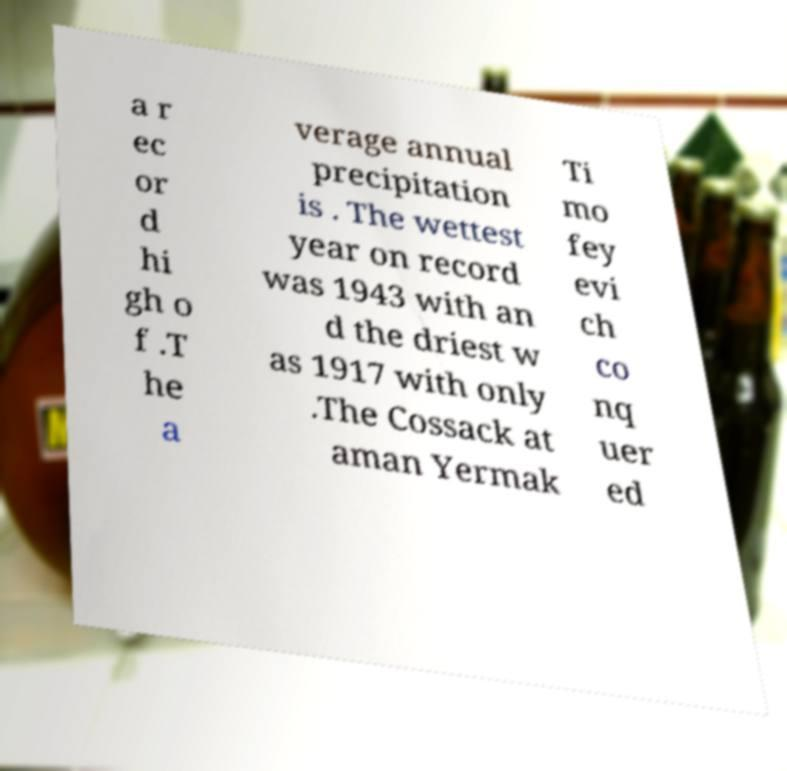Can you accurately transcribe the text from the provided image for me? a r ec or d hi gh o f .T he a verage annual precipitation is . The wettest year on record was 1943 with an d the driest w as 1917 with only .The Cossack at aman Yermak Ti mo fey evi ch co nq uer ed 